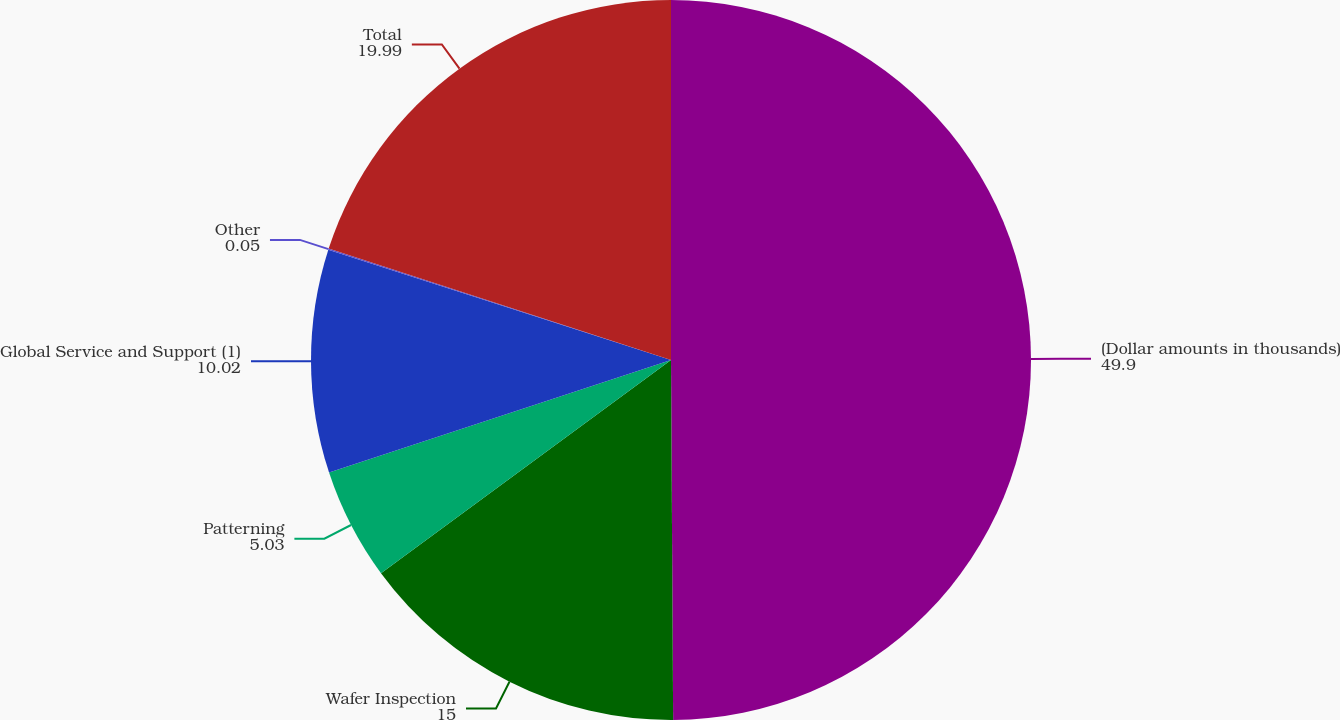<chart> <loc_0><loc_0><loc_500><loc_500><pie_chart><fcel>(Dollar amounts in thousands)<fcel>Wafer Inspection<fcel>Patterning<fcel>Global Service and Support (1)<fcel>Other<fcel>Total<nl><fcel>49.9%<fcel>15.0%<fcel>5.03%<fcel>10.02%<fcel>0.05%<fcel>19.99%<nl></chart> 